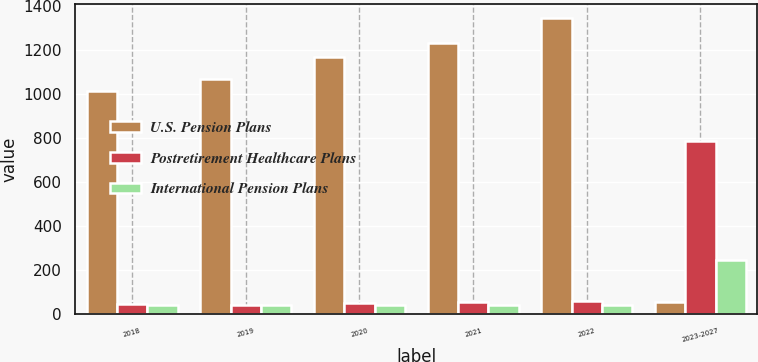<chart> <loc_0><loc_0><loc_500><loc_500><stacked_bar_chart><ecel><fcel>2018<fcel>2019<fcel>2020<fcel>2021<fcel>2022<fcel>2023-2027<nl><fcel>U.S. Pension Plans<fcel>1013<fcel>1070<fcel>1169<fcel>1233<fcel>1345<fcel>53<nl><fcel>Postretirement Healthcare Plans<fcel>44<fcel>43<fcel>48<fcel>53<fcel>59<fcel>789<nl><fcel>International Pension Plans<fcel>39<fcel>40<fcel>42<fcel>42<fcel>43<fcel>246<nl></chart> 